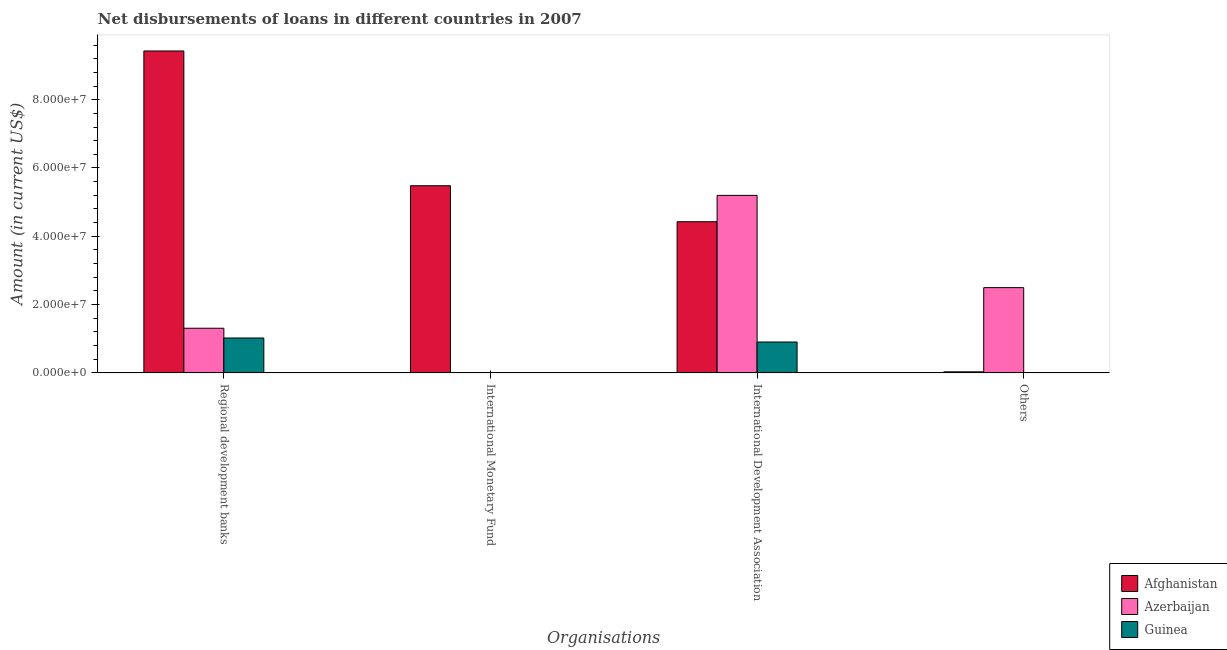How many different coloured bars are there?
Provide a short and direct response. 3. How many bars are there on the 4th tick from the left?
Offer a terse response. 2. How many bars are there on the 3rd tick from the right?
Give a very brief answer. 1. What is the label of the 4th group of bars from the left?
Your answer should be very brief. Others. What is the amount of loan disimbursed by other organisations in Afghanistan?
Give a very brief answer. 3.00e+05. Across all countries, what is the maximum amount of loan disimbursed by international development association?
Provide a succinct answer. 5.20e+07. Across all countries, what is the minimum amount of loan disimbursed by international development association?
Ensure brevity in your answer.  9.04e+06. In which country was the amount of loan disimbursed by other organisations maximum?
Make the answer very short. Azerbaijan. What is the total amount of loan disimbursed by regional development banks in the graph?
Your answer should be compact. 1.18e+08. What is the difference between the amount of loan disimbursed by regional development banks in Afghanistan and that in Guinea?
Provide a short and direct response. 8.41e+07. What is the difference between the amount of loan disimbursed by international development association in Guinea and the amount of loan disimbursed by international monetary fund in Afghanistan?
Provide a succinct answer. -4.58e+07. What is the average amount of loan disimbursed by international monetary fund per country?
Your answer should be compact. 1.83e+07. What is the difference between the amount of loan disimbursed by international monetary fund and amount of loan disimbursed by regional development banks in Afghanistan?
Keep it short and to the point. -3.95e+07. In how many countries, is the amount of loan disimbursed by regional development banks greater than 12000000 US$?
Provide a succinct answer. 2. What is the ratio of the amount of loan disimbursed by international development association in Guinea to that in Afghanistan?
Provide a succinct answer. 0.2. Is the amount of loan disimbursed by regional development banks in Guinea less than that in Azerbaijan?
Your answer should be very brief. Yes. Is the difference between the amount of loan disimbursed by international development association in Azerbaijan and Guinea greater than the difference between the amount of loan disimbursed by regional development banks in Azerbaijan and Guinea?
Make the answer very short. Yes. What is the difference between the highest and the second highest amount of loan disimbursed by international development association?
Give a very brief answer. 7.71e+06. What is the difference between the highest and the lowest amount of loan disimbursed by international monetary fund?
Ensure brevity in your answer.  5.48e+07. Is the sum of the amount of loan disimbursed by other organisations in Azerbaijan and Afghanistan greater than the maximum amount of loan disimbursed by international development association across all countries?
Offer a very short reply. No. Is it the case that in every country, the sum of the amount of loan disimbursed by regional development banks and amount of loan disimbursed by international monetary fund is greater than the amount of loan disimbursed by international development association?
Keep it short and to the point. No. How many bars are there?
Your answer should be very brief. 9. What is the difference between two consecutive major ticks on the Y-axis?
Give a very brief answer. 2.00e+07. Does the graph contain grids?
Offer a terse response. No. Where does the legend appear in the graph?
Give a very brief answer. Bottom right. How are the legend labels stacked?
Offer a very short reply. Vertical. What is the title of the graph?
Ensure brevity in your answer.  Net disbursements of loans in different countries in 2007. Does "Burkina Faso" appear as one of the legend labels in the graph?
Provide a short and direct response. No. What is the label or title of the X-axis?
Ensure brevity in your answer.  Organisations. What is the label or title of the Y-axis?
Your answer should be compact. Amount (in current US$). What is the Amount (in current US$) of Afghanistan in Regional development banks?
Provide a succinct answer. 9.43e+07. What is the Amount (in current US$) in Azerbaijan in Regional development banks?
Provide a succinct answer. 1.31e+07. What is the Amount (in current US$) in Guinea in Regional development banks?
Keep it short and to the point. 1.02e+07. What is the Amount (in current US$) in Afghanistan in International Monetary Fund?
Offer a terse response. 5.48e+07. What is the Amount (in current US$) in Afghanistan in International Development Association?
Ensure brevity in your answer.  4.43e+07. What is the Amount (in current US$) of Azerbaijan in International Development Association?
Provide a succinct answer. 5.20e+07. What is the Amount (in current US$) of Guinea in International Development Association?
Your answer should be very brief. 9.04e+06. What is the Amount (in current US$) of Azerbaijan in Others?
Offer a terse response. 2.50e+07. Across all Organisations, what is the maximum Amount (in current US$) in Afghanistan?
Give a very brief answer. 9.43e+07. Across all Organisations, what is the maximum Amount (in current US$) of Azerbaijan?
Provide a short and direct response. 5.20e+07. Across all Organisations, what is the maximum Amount (in current US$) in Guinea?
Provide a short and direct response. 1.02e+07. Across all Organisations, what is the minimum Amount (in current US$) of Afghanistan?
Keep it short and to the point. 3.00e+05. Across all Organisations, what is the minimum Amount (in current US$) of Guinea?
Provide a short and direct response. 0. What is the total Amount (in current US$) in Afghanistan in the graph?
Offer a very short reply. 1.94e+08. What is the total Amount (in current US$) of Azerbaijan in the graph?
Provide a short and direct response. 9.00e+07. What is the total Amount (in current US$) in Guinea in the graph?
Keep it short and to the point. 1.92e+07. What is the difference between the Amount (in current US$) in Afghanistan in Regional development banks and that in International Monetary Fund?
Offer a very short reply. 3.95e+07. What is the difference between the Amount (in current US$) of Afghanistan in Regional development banks and that in International Development Association?
Ensure brevity in your answer.  5.00e+07. What is the difference between the Amount (in current US$) in Azerbaijan in Regional development banks and that in International Development Association?
Keep it short and to the point. -3.89e+07. What is the difference between the Amount (in current US$) of Guinea in Regional development banks and that in International Development Association?
Give a very brief answer. 1.18e+06. What is the difference between the Amount (in current US$) of Afghanistan in Regional development banks and that in Others?
Make the answer very short. 9.40e+07. What is the difference between the Amount (in current US$) of Azerbaijan in Regional development banks and that in Others?
Give a very brief answer. -1.19e+07. What is the difference between the Amount (in current US$) in Afghanistan in International Monetary Fund and that in International Development Association?
Give a very brief answer. 1.05e+07. What is the difference between the Amount (in current US$) in Afghanistan in International Monetary Fund and that in Others?
Your response must be concise. 5.45e+07. What is the difference between the Amount (in current US$) in Afghanistan in International Development Association and that in Others?
Offer a terse response. 4.40e+07. What is the difference between the Amount (in current US$) of Azerbaijan in International Development Association and that in Others?
Provide a short and direct response. 2.70e+07. What is the difference between the Amount (in current US$) of Afghanistan in Regional development banks and the Amount (in current US$) of Azerbaijan in International Development Association?
Provide a short and direct response. 4.23e+07. What is the difference between the Amount (in current US$) of Afghanistan in Regional development banks and the Amount (in current US$) of Guinea in International Development Association?
Offer a very short reply. 8.52e+07. What is the difference between the Amount (in current US$) in Azerbaijan in Regional development banks and the Amount (in current US$) in Guinea in International Development Association?
Make the answer very short. 4.03e+06. What is the difference between the Amount (in current US$) of Afghanistan in Regional development banks and the Amount (in current US$) of Azerbaijan in Others?
Give a very brief answer. 6.93e+07. What is the difference between the Amount (in current US$) in Afghanistan in International Monetary Fund and the Amount (in current US$) in Azerbaijan in International Development Association?
Give a very brief answer. 2.82e+06. What is the difference between the Amount (in current US$) of Afghanistan in International Monetary Fund and the Amount (in current US$) of Guinea in International Development Association?
Offer a very short reply. 4.58e+07. What is the difference between the Amount (in current US$) in Afghanistan in International Monetary Fund and the Amount (in current US$) in Azerbaijan in Others?
Offer a very short reply. 2.98e+07. What is the difference between the Amount (in current US$) of Afghanistan in International Development Association and the Amount (in current US$) of Azerbaijan in Others?
Give a very brief answer. 1.93e+07. What is the average Amount (in current US$) in Afghanistan per Organisations?
Your response must be concise. 4.84e+07. What is the average Amount (in current US$) of Azerbaijan per Organisations?
Give a very brief answer. 2.25e+07. What is the average Amount (in current US$) in Guinea per Organisations?
Make the answer very short. 4.81e+06. What is the difference between the Amount (in current US$) of Afghanistan and Amount (in current US$) of Azerbaijan in Regional development banks?
Your response must be concise. 8.12e+07. What is the difference between the Amount (in current US$) of Afghanistan and Amount (in current US$) of Guinea in Regional development banks?
Give a very brief answer. 8.41e+07. What is the difference between the Amount (in current US$) in Azerbaijan and Amount (in current US$) in Guinea in Regional development banks?
Keep it short and to the point. 2.86e+06. What is the difference between the Amount (in current US$) in Afghanistan and Amount (in current US$) in Azerbaijan in International Development Association?
Your answer should be compact. -7.71e+06. What is the difference between the Amount (in current US$) of Afghanistan and Amount (in current US$) of Guinea in International Development Association?
Provide a succinct answer. 3.52e+07. What is the difference between the Amount (in current US$) of Azerbaijan and Amount (in current US$) of Guinea in International Development Association?
Your answer should be very brief. 4.29e+07. What is the difference between the Amount (in current US$) in Afghanistan and Amount (in current US$) in Azerbaijan in Others?
Give a very brief answer. -2.47e+07. What is the ratio of the Amount (in current US$) of Afghanistan in Regional development banks to that in International Monetary Fund?
Ensure brevity in your answer.  1.72. What is the ratio of the Amount (in current US$) in Afghanistan in Regional development banks to that in International Development Association?
Make the answer very short. 2.13. What is the ratio of the Amount (in current US$) of Azerbaijan in Regional development banks to that in International Development Association?
Keep it short and to the point. 0.25. What is the ratio of the Amount (in current US$) in Guinea in Regional development banks to that in International Development Association?
Make the answer very short. 1.13. What is the ratio of the Amount (in current US$) in Afghanistan in Regional development banks to that in Others?
Give a very brief answer. 314.25. What is the ratio of the Amount (in current US$) in Azerbaijan in Regional development banks to that in Others?
Ensure brevity in your answer.  0.52. What is the ratio of the Amount (in current US$) in Afghanistan in International Monetary Fund to that in International Development Association?
Provide a succinct answer. 1.24. What is the ratio of the Amount (in current US$) in Afghanistan in International Monetary Fund to that in Others?
Provide a short and direct response. 182.69. What is the ratio of the Amount (in current US$) in Afghanistan in International Development Association to that in Others?
Offer a very short reply. 147.57. What is the ratio of the Amount (in current US$) in Azerbaijan in International Development Association to that in Others?
Your response must be concise. 2.08. What is the difference between the highest and the second highest Amount (in current US$) in Afghanistan?
Ensure brevity in your answer.  3.95e+07. What is the difference between the highest and the second highest Amount (in current US$) in Azerbaijan?
Your answer should be very brief. 2.70e+07. What is the difference between the highest and the lowest Amount (in current US$) of Afghanistan?
Your answer should be compact. 9.40e+07. What is the difference between the highest and the lowest Amount (in current US$) in Azerbaijan?
Keep it short and to the point. 5.20e+07. What is the difference between the highest and the lowest Amount (in current US$) in Guinea?
Your response must be concise. 1.02e+07. 